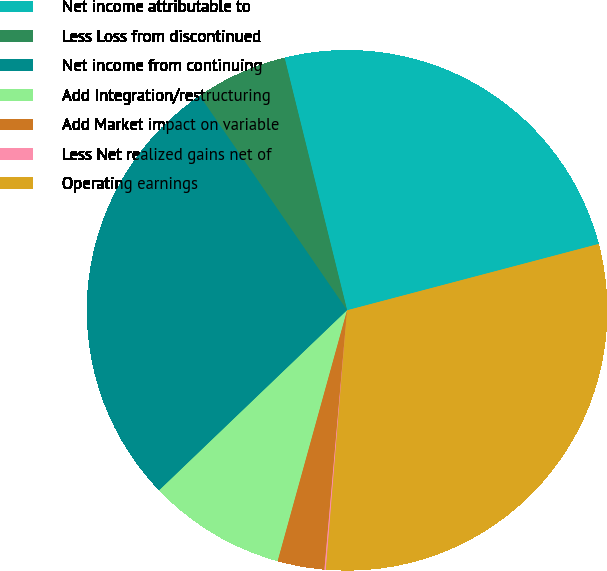Convert chart to OTSL. <chart><loc_0><loc_0><loc_500><loc_500><pie_chart><fcel>Net income attributable to<fcel>Less Loss from discontinued<fcel>Net income from continuing<fcel>Add Integration/restructuring<fcel>Add Market impact on variable<fcel>Less Net realized gains net of<fcel>Operating earnings<nl><fcel>24.76%<fcel>5.72%<fcel>27.58%<fcel>8.54%<fcel>2.91%<fcel>0.09%<fcel>30.4%<nl></chart> 